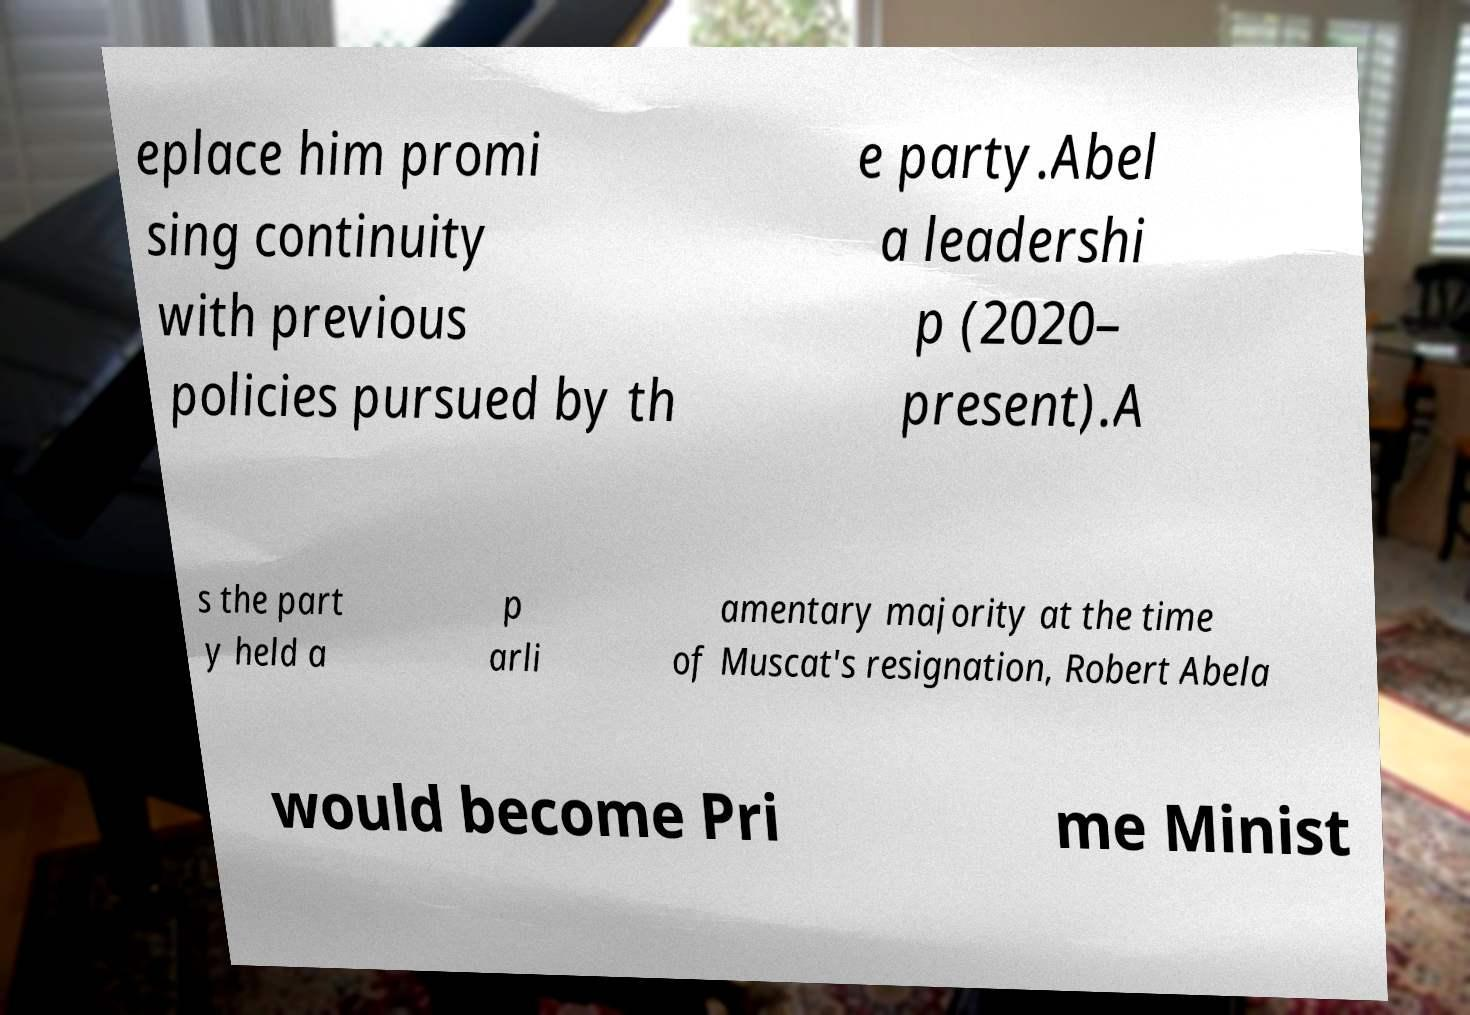Please identify and transcribe the text found in this image. eplace him promi sing continuity with previous policies pursued by th e party.Abel a leadershi p (2020– present).A s the part y held a p arli amentary majority at the time of Muscat's resignation, Robert Abela would become Pri me Minist 